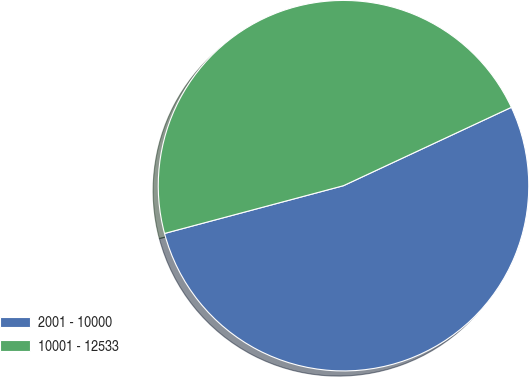<chart> <loc_0><loc_0><loc_500><loc_500><pie_chart><fcel>2001 - 10000<fcel>10001 - 12533<nl><fcel>52.8%<fcel>47.2%<nl></chart> 